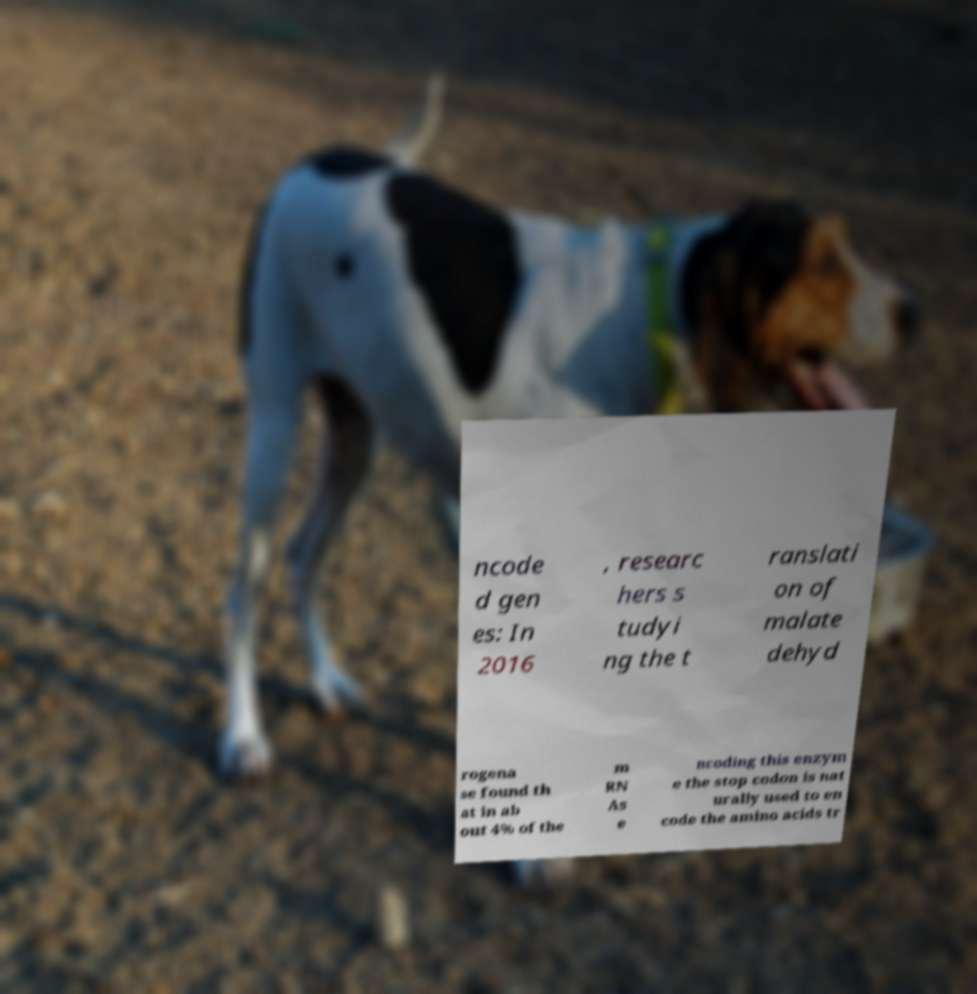For documentation purposes, I need the text within this image transcribed. Could you provide that? ncode d gen es: In 2016 , researc hers s tudyi ng the t ranslati on of malate dehyd rogena se found th at in ab out 4% of the m RN As e ncoding this enzym e the stop codon is nat urally used to en code the amino acids tr 